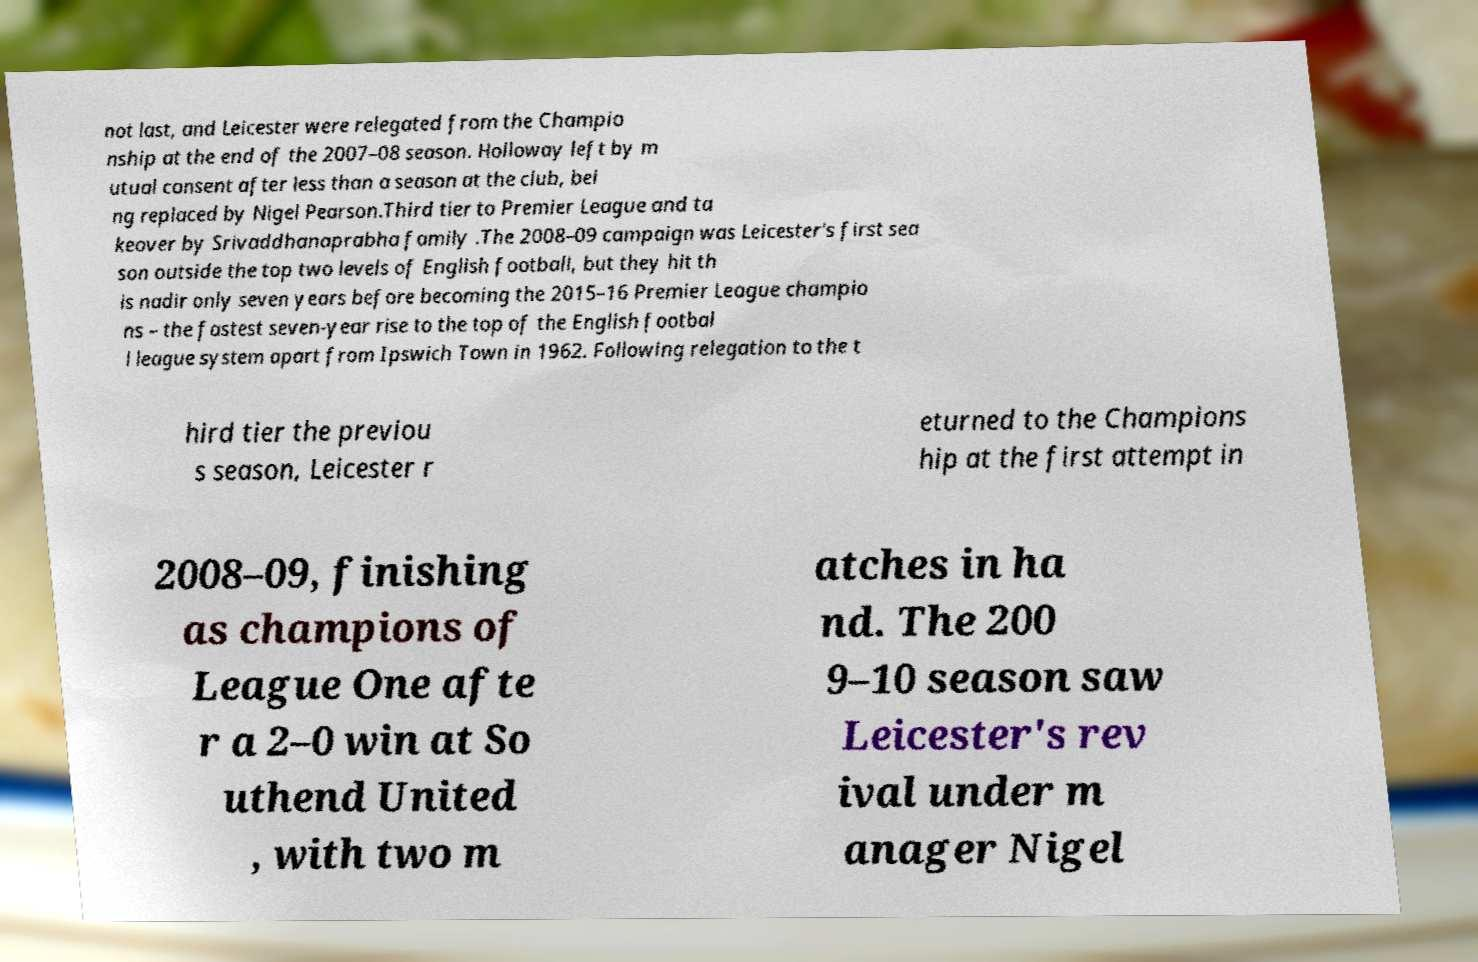I need the written content from this picture converted into text. Can you do that? not last, and Leicester were relegated from the Champio nship at the end of the 2007–08 season. Holloway left by m utual consent after less than a season at the club, bei ng replaced by Nigel Pearson.Third tier to Premier League and ta keover by Srivaddhanaprabha family .The 2008–09 campaign was Leicester's first sea son outside the top two levels of English football, but they hit th is nadir only seven years before becoming the 2015–16 Premier League champio ns – the fastest seven-year rise to the top of the English footbal l league system apart from Ipswich Town in 1962. Following relegation to the t hird tier the previou s season, Leicester r eturned to the Champions hip at the first attempt in 2008–09, finishing as champions of League One afte r a 2–0 win at So uthend United , with two m atches in ha nd. The 200 9–10 season saw Leicester's rev ival under m anager Nigel 